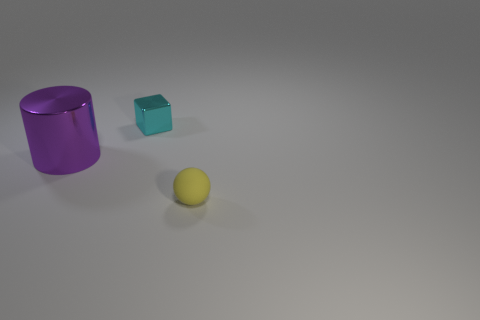Add 3 small balls. How many objects exist? 6 Subtract 1 blocks. How many blocks are left? 0 Subtract all blocks. How many objects are left? 2 Subtract all brown cylinders. How many gray spheres are left? 0 Subtract all large purple cylinders. Subtract all rubber spheres. How many objects are left? 1 Add 2 shiny cylinders. How many shiny cylinders are left? 3 Add 2 cylinders. How many cylinders exist? 3 Subtract 0 purple cubes. How many objects are left? 3 Subtract all brown balls. Subtract all cyan cylinders. How many balls are left? 1 